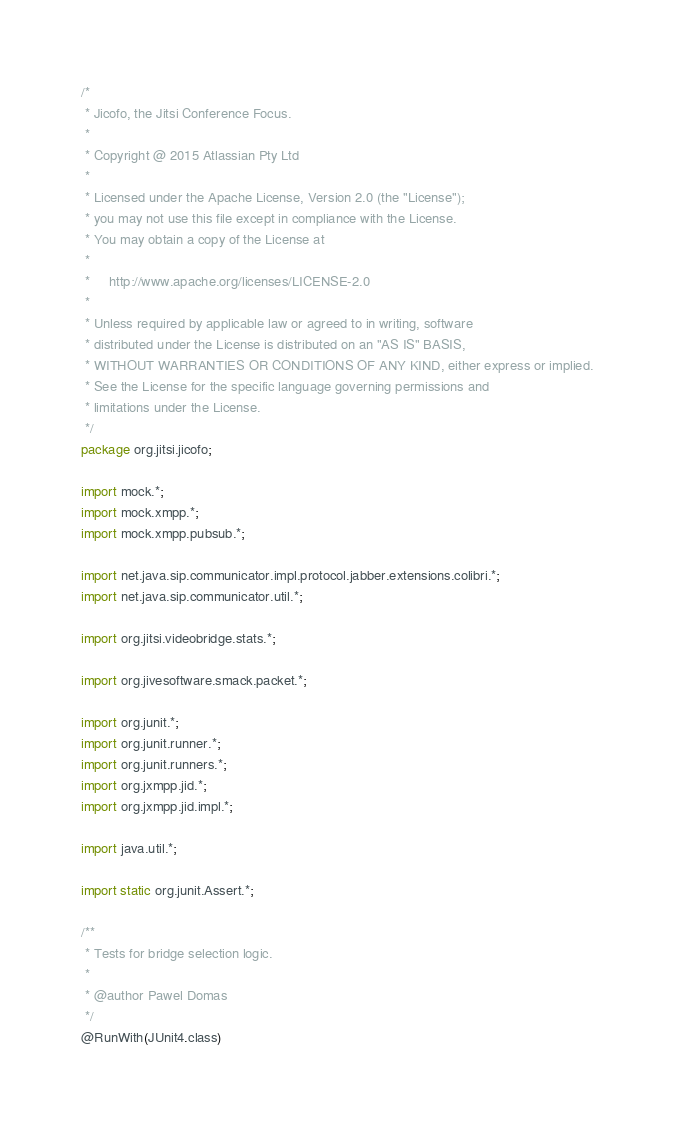Convert code to text. <code><loc_0><loc_0><loc_500><loc_500><_Java_>/*
 * Jicofo, the Jitsi Conference Focus.
 *
 * Copyright @ 2015 Atlassian Pty Ltd
 *
 * Licensed under the Apache License, Version 2.0 (the "License");
 * you may not use this file except in compliance with the License.
 * You may obtain a copy of the License at
 *
 *     http://www.apache.org/licenses/LICENSE-2.0
 *
 * Unless required by applicable law or agreed to in writing, software
 * distributed under the License is distributed on an "AS IS" BASIS,
 * WITHOUT WARRANTIES OR CONDITIONS OF ANY KIND, either express or implied.
 * See the License for the specific language governing permissions and
 * limitations under the License.
 */
package org.jitsi.jicofo;

import mock.*;
import mock.xmpp.*;
import mock.xmpp.pubsub.*;

import net.java.sip.communicator.impl.protocol.jabber.extensions.colibri.*;
import net.java.sip.communicator.util.*;

import org.jitsi.videobridge.stats.*;

import org.jivesoftware.smack.packet.*;

import org.junit.*;
import org.junit.runner.*;
import org.junit.runners.*;
import org.jxmpp.jid.*;
import org.jxmpp.jid.impl.*;

import java.util.*;

import static org.junit.Assert.*;

/**
 * Tests for bridge selection logic.
 *
 * @author Pawel Domas
 */
@RunWith(JUnit4.class)</code> 